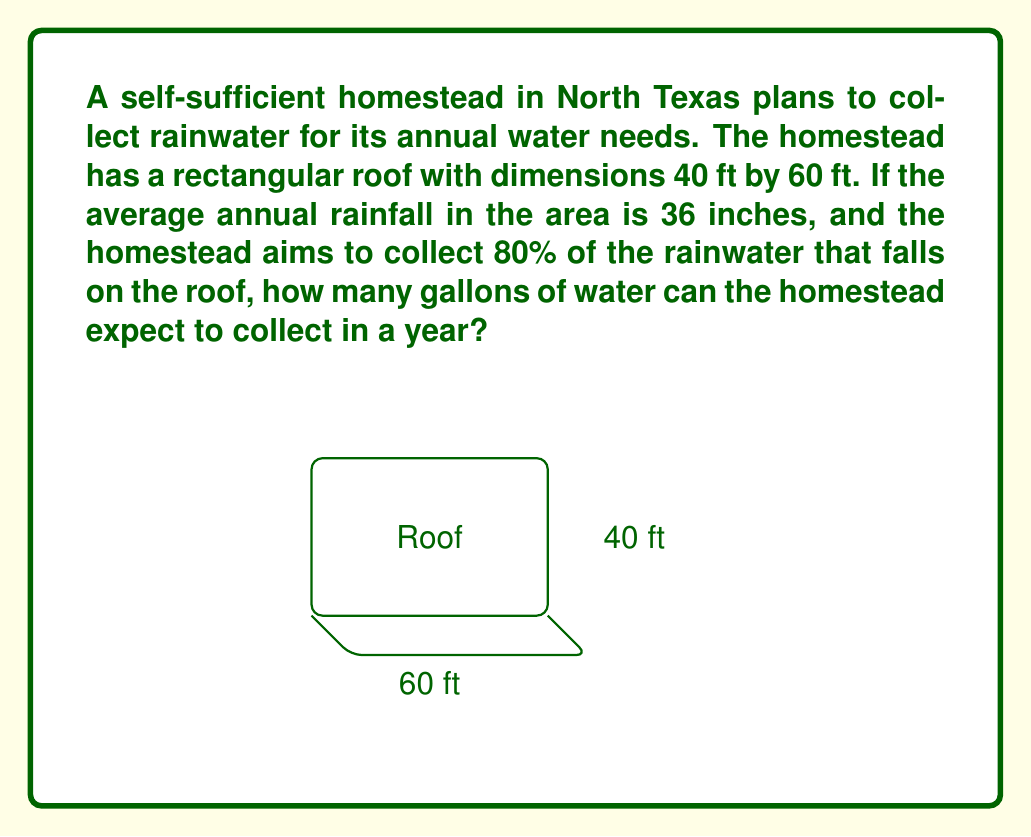Teach me how to tackle this problem. Let's approach this step-by-step:

1) First, calculate the area of the roof:
   $A = 40 \text{ ft} \times 60 \text{ ft} = 2400 \text{ sq ft}$

2) Convert the annual rainfall from inches to feet:
   $36 \text{ inches} = 36 \div 12 = 3 \text{ ft}$

3) Calculate the total volume of rainwater that falls on the roof:
   $V = A \times h = 2400 \text{ sq ft} \times 3 \text{ ft} = 7200 \text{ cu ft}$

4) Account for the 80% collection efficiency:
   $V_{\text{collected}} = 7200 \text{ cu ft} \times 0.80 = 5760 \text{ cu ft}$

5) Convert cubic feet to gallons:
   1 cubic foot = 7.48052 gallons
   $V_{\text{gallons}} = 5760 \text{ cu ft} \times 7.48052 \text{ gal/cu ft} = 43088.20 \text{ gallons}$

Therefore, the homestead can expect to collect approximately 43,088 gallons of water in a year.
Answer: 43,088 gallons 